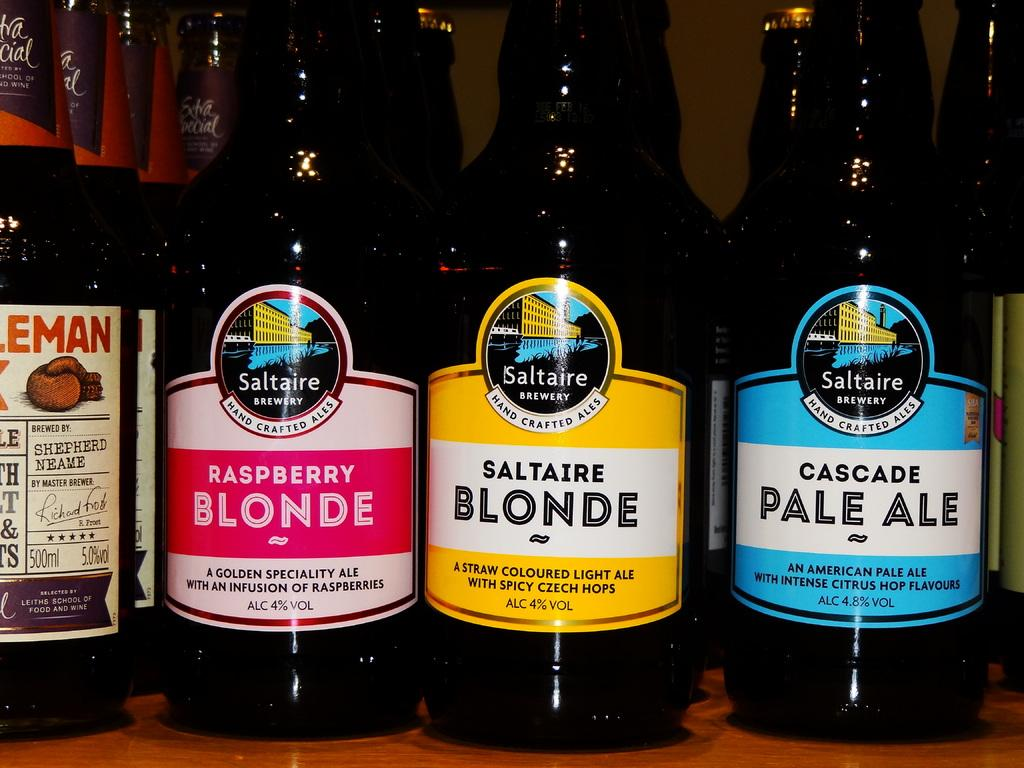Provide a one-sentence caption for the provided image. Lined up bottles of beverages in bottles called Saltaire Brewery hand crafted ale lined up on a bar shelf. 